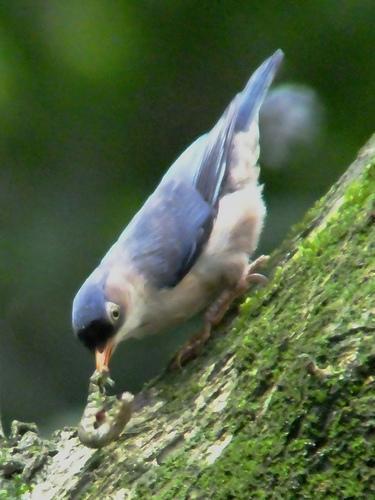How many birds are there?
Give a very brief answer. 1. 